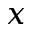Convert formula to latex. <formula><loc_0><loc_0><loc_500><loc_500>x</formula> 